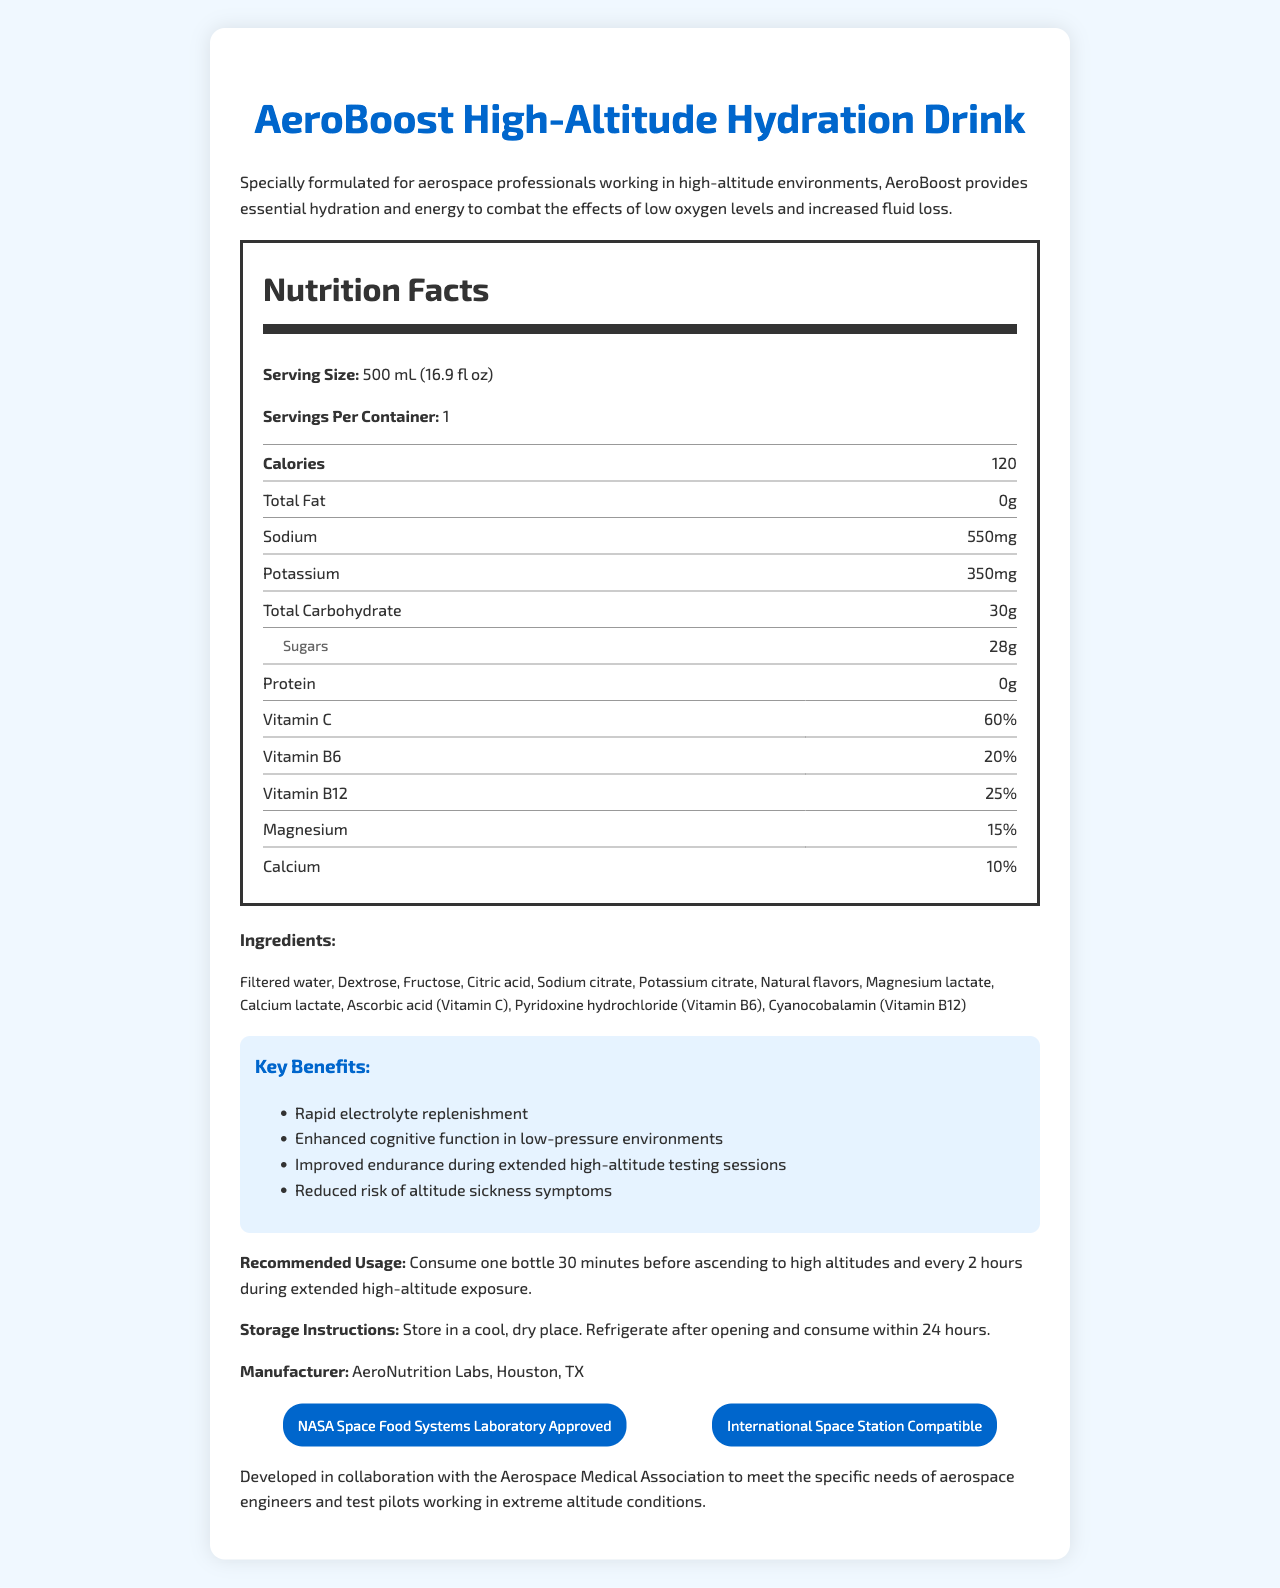what is the serving size of AeroBoost High-Altitude Hydration Drink? The serving size is mentioned at the top of the Nutrition Facts section: "Serving Size: 500 mL (16.9 fl oz)".
Answer: 500 mL (16.9 fl oz) how many calories are there per container? The calories per container are indicated in the Nutrition Facts section: "Calories 120".
Answer: 120 what is the sodium content in the drink? The sodium content is listed in the Nutrition Facts section: "Sodium 550 mg".
Answer: 550 mg what are the key benefits of consuming the product? The key benefits are specified in the "Key Benefits" section.
Answer: Rapid electrolyte replenishment, Enhanced cognitive function in low-pressure environments, Improved endurance during extended high-altitude testing sessions, Reduced risk of altitude sickness symptoms what are the vitamin percentages in the drink? These percentages are listed in the Nutrition Facts section under the vitamin sub-section.
Answer: Vitamin C 60%, Vitamin B6 20%, Vitamin B12 25%, Magnesium 15%, Calcium 10% which ingredient is used as a source of Vitamin C? 
A. Dextrose 
B. Ascorbic acid 
C. Magnesium lactate 
D. Sodium citrate The ingredient list mentions "Ascorbic acid (Vitamin C)" specifically.
Answer: B how much total carbohydrate does the drink contain? 
i. 28g 
ii. 30g 
iii. 32g 
iv. 35g The total carbohydrate content is mentioned in the Nutrition Facts section: "Total Carbohydrate 30g".
Answer: ii is AeroBoost High-Altitude Hydration Drink NASA Space Food Systems Laboratory Approved? The certification section mentions "NASA Space Food Systems Laboratory Approved".
Answer: Yes describe the main idea of the document in one sentence. The document's content comprehensively covers various aspects of the AeroBoost High-Altitude Hydration Drink, highlighting its suitability for aerospace engineers and test pilots.
Answer: The document provides detailed nutrition facts, ingredients, key benefits, certifications, and usage instructions for the AeroBoost High-Altitude Hydration Drink, specially formulated for aerospace professionals. what is the daily recommended intake of protein according to the drink’s nutrition facts? The drink lists 0g of protein in the Nutrition Facts section, but it does not specify the daily recommended intake.
Answer: Not provided how long can the drink be stored after opening? The document specifies in the Storage Instructions: "Refrigerate after opening and consume within 24 hours".
Answer: 24 hours 